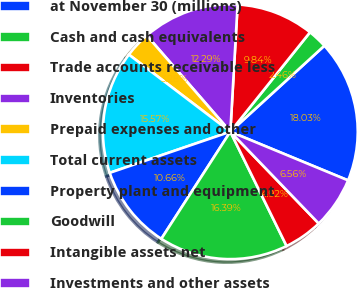Convert chart to OTSL. <chart><loc_0><loc_0><loc_500><loc_500><pie_chart><fcel>at November 30 (millions)<fcel>Cash and cash equivalents<fcel>Trade accounts receivable less<fcel>Inventories<fcel>Prepaid expenses and other<fcel>Total current assets<fcel>Property plant and equipment<fcel>Goodwill<fcel>Intangible assets net<fcel>Investments and other assets<nl><fcel>18.03%<fcel>2.46%<fcel>9.84%<fcel>12.29%<fcel>3.28%<fcel>15.57%<fcel>10.66%<fcel>16.39%<fcel>4.92%<fcel>6.56%<nl></chart> 